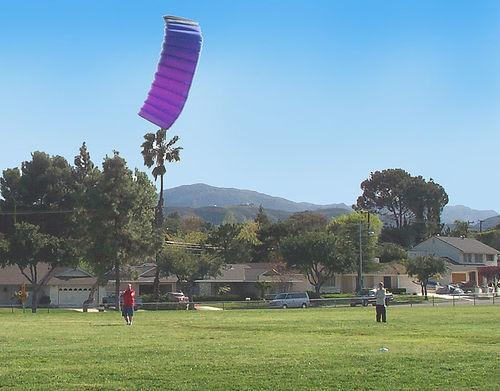What does the man in red hold in his hands?

Choices:
A) bait
B) kite strings
C) food
D) nothing kite strings 